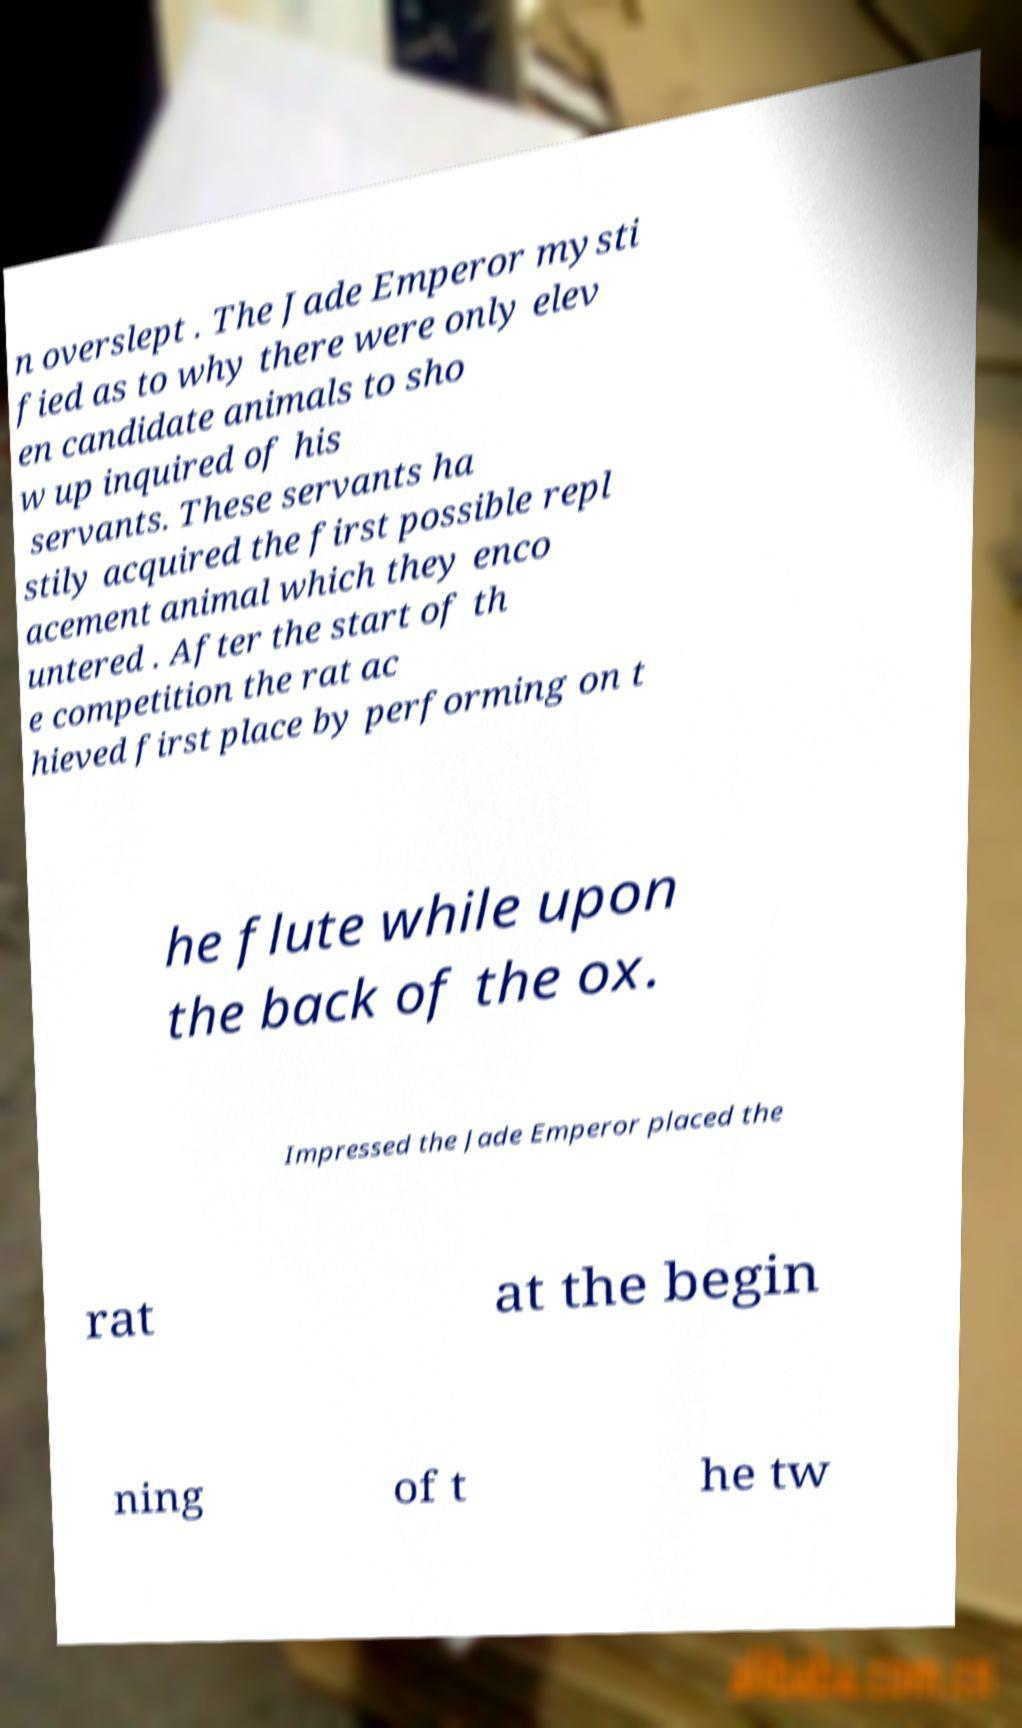Please read and relay the text visible in this image. What does it say? n overslept . The Jade Emperor mysti fied as to why there were only elev en candidate animals to sho w up inquired of his servants. These servants ha stily acquired the first possible repl acement animal which they enco untered . After the start of th e competition the rat ac hieved first place by performing on t he flute while upon the back of the ox. Impressed the Jade Emperor placed the rat at the begin ning of t he tw 